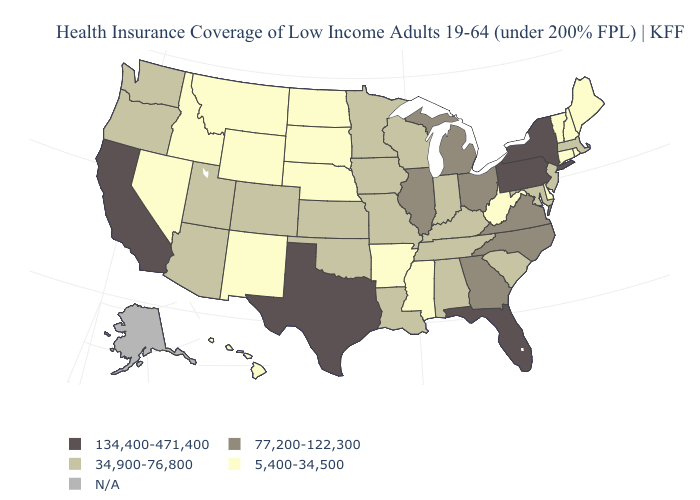Does Idaho have the lowest value in the West?
Answer briefly. Yes. Name the states that have a value in the range 77,200-122,300?
Short answer required. Georgia, Illinois, Michigan, North Carolina, Ohio, Virginia. Does the first symbol in the legend represent the smallest category?
Be succinct. No. Name the states that have a value in the range N/A?
Give a very brief answer. Alaska. Name the states that have a value in the range 34,900-76,800?
Short answer required. Alabama, Arizona, Colorado, Indiana, Iowa, Kansas, Kentucky, Louisiana, Maryland, Massachusetts, Minnesota, Missouri, New Jersey, Oklahoma, Oregon, South Carolina, Tennessee, Utah, Washington, Wisconsin. Among the states that border Tennessee , which have the highest value?
Be succinct. Georgia, North Carolina, Virginia. What is the value of Georgia?
Write a very short answer. 77,200-122,300. Does the first symbol in the legend represent the smallest category?
Write a very short answer. No. What is the value of Arkansas?
Keep it brief. 5,400-34,500. Name the states that have a value in the range N/A?
Answer briefly. Alaska. What is the lowest value in the USA?
Give a very brief answer. 5,400-34,500. Name the states that have a value in the range N/A?
Give a very brief answer. Alaska. 